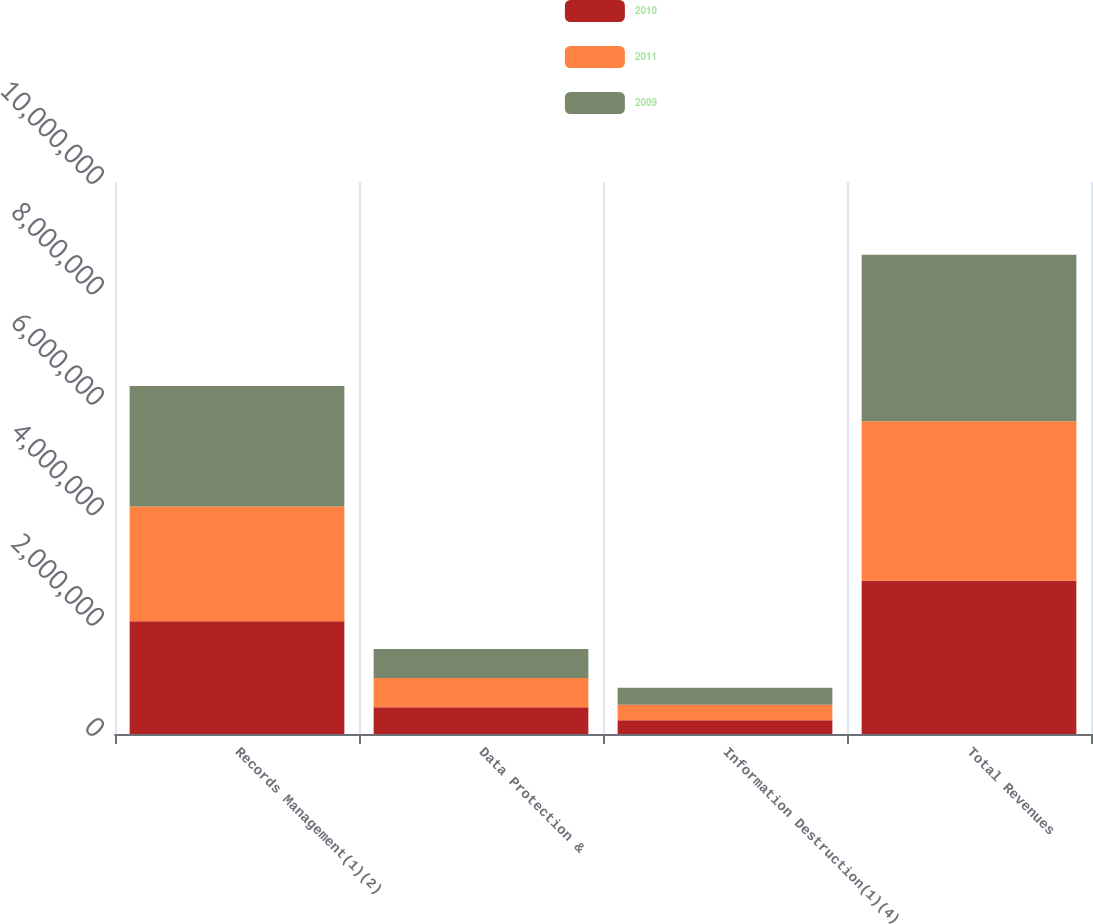Convert chart. <chart><loc_0><loc_0><loc_500><loc_500><stacked_bar_chart><ecel><fcel>Records Management(1)(2)<fcel>Data Protection &<fcel>Information Destruction(1)(4)<fcel>Total Revenues<nl><fcel>2010<fcel>2.0405e+06<fcel>483909<fcel>249978<fcel>2.77438e+06<nl><fcel>2011<fcel>2.08149e+06<fcel>531580<fcel>279277<fcel>2.89235e+06<nl><fcel>2009<fcel>2.18315e+06<fcel>522632<fcel>308917<fcel>3.0147e+06<nl></chart> 